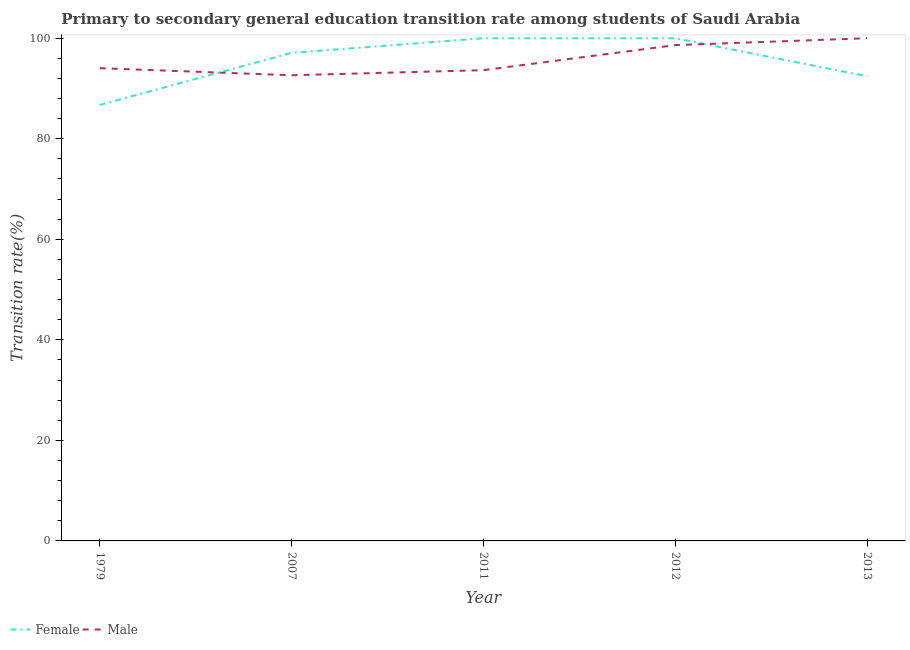How many different coloured lines are there?
Offer a very short reply. 2. Is the number of lines equal to the number of legend labels?
Your answer should be very brief. Yes. What is the transition rate among male students in 2013?
Make the answer very short. 100. Across all years, what is the minimum transition rate among male students?
Provide a short and direct response. 92.63. In which year was the transition rate among male students maximum?
Ensure brevity in your answer.  2013. In which year was the transition rate among female students minimum?
Ensure brevity in your answer.  1979. What is the total transition rate among female students in the graph?
Your response must be concise. 476.25. What is the difference between the transition rate among male students in 1979 and that in 2012?
Your answer should be very brief. -4.58. What is the difference between the transition rate among male students in 2013 and the transition rate among female students in 2007?
Make the answer very short. 2.91. What is the average transition rate among male students per year?
Your response must be concise. 95.79. In the year 2012, what is the difference between the transition rate among female students and transition rate among male students?
Your answer should be very brief. 1.37. In how many years, is the transition rate among male students greater than 40 %?
Keep it short and to the point. 5. What is the ratio of the transition rate among male students in 2011 to that in 2013?
Make the answer very short. 0.94. Is the transition rate among male students in 2007 less than that in 2013?
Your answer should be compact. Yes. Is the difference between the transition rate among male students in 2012 and 2013 greater than the difference between the transition rate among female students in 2012 and 2013?
Offer a terse response. No. What is the difference between the highest and the lowest transition rate among male students?
Your answer should be compact. 7.37. Is the transition rate among male students strictly greater than the transition rate among female students over the years?
Offer a very short reply. No. Is the transition rate among female students strictly less than the transition rate among male students over the years?
Provide a short and direct response. No. How many years are there in the graph?
Your answer should be very brief. 5. Does the graph contain any zero values?
Make the answer very short. No. Does the graph contain grids?
Your answer should be compact. No. Where does the legend appear in the graph?
Offer a terse response. Bottom left. How are the legend labels stacked?
Make the answer very short. Horizontal. What is the title of the graph?
Make the answer very short. Primary to secondary general education transition rate among students of Saudi Arabia. Does "Commercial service exports" appear as one of the legend labels in the graph?
Provide a short and direct response. No. What is the label or title of the Y-axis?
Offer a terse response. Transition rate(%). What is the Transition rate(%) of Female in 1979?
Offer a very short reply. 86.72. What is the Transition rate(%) of Male in 1979?
Provide a succinct answer. 94.04. What is the Transition rate(%) in Female in 2007?
Make the answer very short. 97.09. What is the Transition rate(%) of Male in 2007?
Provide a succinct answer. 92.63. What is the Transition rate(%) of Female in 2011?
Offer a terse response. 100. What is the Transition rate(%) in Male in 2011?
Offer a very short reply. 93.65. What is the Transition rate(%) in Female in 2012?
Make the answer very short. 100. What is the Transition rate(%) in Male in 2012?
Your response must be concise. 98.63. What is the Transition rate(%) in Female in 2013?
Provide a succinct answer. 92.43. Across all years, what is the maximum Transition rate(%) in Female?
Your answer should be compact. 100. Across all years, what is the maximum Transition rate(%) in Male?
Offer a terse response. 100. Across all years, what is the minimum Transition rate(%) of Female?
Your answer should be compact. 86.72. Across all years, what is the minimum Transition rate(%) of Male?
Offer a very short reply. 92.63. What is the total Transition rate(%) in Female in the graph?
Make the answer very short. 476.25. What is the total Transition rate(%) of Male in the graph?
Your response must be concise. 478.95. What is the difference between the Transition rate(%) of Female in 1979 and that in 2007?
Provide a short and direct response. -10.36. What is the difference between the Transition rate(%) of Male in 1979 and that in 2007?
Ensure brevity in your answer.  1.41. What is the difference between the Transition rate(%) of Female in 1979 and that in 2011?
Your response must be concise. -13.28. What is the difference between the Transition rate(%) in Male in 1979 and that in 2011?
Ensure brevity in your answer.  0.4. What is the difference between the Transition rate(%) of Female in 1979 and that in 2012?
Your answer should be very brief. -13.28. What is the difference between the Transition rate(%) of Male in 1979 and that in 2012?
Your answer should be compact. -4.58. What is the difference between the Transition rate(%) of Female in 1979 and that in 2013?
Your answer should be compact. -5.71. What is the difference between the Transition rate(%) in Male in 1979 and that in 2013?
Offer a very short reply. -5.96. What is the difference between the Transition rate(%) in Female in 2007 and that in 2011?
Your answer should be very brief. -2.91. What is the difference between the Transition rate(%) of Male in 2007 and that in 2011?
Give a very brief answer. -1.01. What is the difference between the Transition rate(%) of Female in 2007 and that in 2012?
Ensure brevity in your answer.  -2.91. What is the difference between the Transition rate(%) in Male in 2007 and that in 2012?
Keep it short and to the point. -5.99. What is the difference between the Transition rate(%) of Female in 2007 and that in 2013?
Keep it short and to the point. 4.65. What is the difference between the Transition rate(%) in Male in 2007 and that in 2013?
Offer a terse response. -7.37. What is the difference between the Transition rate(%) of Female in 2011 and that in 2012?
Offer a very short reply. 0. What is the difference between the Transition rate(%) of Male in 2011 and that in 2012?
Ensure brevity in your answer.  -4.98. What is the difference between the Transition rate(%) of Female in 2011 and that in 2013?
Provide a succinct answer. 7.57. What is the difference between the Transition rate(%) of Male in 2011 and that in 2013?
Provide a succinct answer. -6.35. What is the difference between the Transition rate(%) in Female in 2012 and that in 2013?
Make the answer very short. 7.57. What is the difference between the Transition rate(%) in Male in 2012 and that in 2013?
Keep it short and to the point. -1.37. What is the difference between the Transition rate(%) in Female in 1979 and the Transition rate(%) in Male in 2007?
Ensure brevity in your answer.  -5.91. What is the difference between the Transition rate(%) in Female in 1979 and the Transition rate(%) in Male in 2011?
Offer a very short reply. -6.92. What is the difference between the Transition rate(%) in Female in 1979 and the Transition rate(%) in Male in 2012?
Provide a succinct answer. -11.9. What is the difference between the Transition rate(%) in Female in 1979 and the Transition rate(%) in Male in 2013?
Your answer should be very brief. -13.28. What is the difference between the Transition rate(%) of Female in 2007 and the Transition rate(%) of Male in 2011?
Your answer should be very brief. 3.44. What is the difference between the Transition rate(%) of Female in 2007 and the Transition rate(%) of Male in 2012?
Offer a terse response. -1.54. What is the difference between the Transition rate(%) in Female in 2007 and the Transition rate(%) in Male in 2013?
Provide a succinct answer. -2.91. What is the difference between the Transition rate(%) of Female in 2011 and the Transition rate(%) of Male in 2012?
Offer a very short reply. 1.37. What is the difference between the Transition rate(%) of Female in 2011 and the Transition rate(%) of Male in 2013?
Your answer should be compact. 0. What is the average Transition rate(%) in Female per year?
Your response must be concise. 95.25. What is the average Transition rate(%) of Male per year?
Your response must be concise. 95.79. In the year 1979, what is the difference between the Transition rate(%) in Female and Transition rate(%) in Male?
Ensure brevity in your answer.  -7.32. In the year 2007, what is the difference between the Transition rate(%) in Female and Transition rate(%) in Male?
Ensure brevity in your answer.  4.46. In the year 2011, what is the difference between the Transition rate(%) in Female and Transition rate(%) in Male?
Offer a terse response. 6.35. In the year 2012, what is the difference between the Transition rate(%) in Female and Transition rate(%) in Male?
Give a very brief answer. 1.37. In the year 2013, what is the difference between the Transition rate(%) of Female and Transition rate(%) of Male?
Ensure brevity in your answer.  -7.57. What is the ratio of the Transition rate(%) in Female in 1979 to that in 2007?
Provide a short and direct response. 0.89. What is the ratio of the Transition rate(%) of Male in 1979 to that in 2007?
Your answer should be very brief. 1.02. What is the ratio of the Transition rate(%) in Female in 1979 to that in 2011?
Offer a terse response. 0.87. What is the ratio of the Transition rate(%) in Female in 1979 to that in 2012?
Offer a very short reply. 0.87. What is the ratio of the Transition rate(%) in Male in 1979 to that in 2012?
Make the answer very short. 0.95. What is the ratio of the Transition rate(%) in Female in 1979 to that in 2013?
Provide a succinct answer. 0.94. What is the ratio of the Transition rate(%) of Male in 1979 to that in 2013?
Offer a very short reply. 0.94. What is the ratio of the Transition rate(%) in Female in 2007 to that in 2011?
Offer a very short reply. 0.97. What is the ratio of the Transition rate(%) in Female in 2007 to that in 2012?
Ensure brevity in your answer.  0.97. What is the ratio of the Transition rate(%) in Male in 2007 to that in 2012?
Ensure brevity in your answer.  0.94. What is the ratio of the Transition rate(%) in Female in 2007 to that in 2013?
Your answer should be very brief. 1.05. What is the ratio of the Transition rate(%) of Male in 2007 to that in 2013?
Give a very brief answer. 0.93. What is the ratio of the Transition rate(%) of Female in 2011 to that in 2012?
Make the answer very short. 1. What is the ratio of the Transition rate(%) in Male in 2011 to that in 2012?
Offer a terse response. 0.95. What is the ratio of the Transition rate(%) of Female in 2011 to that in 2013?
Make the answer very short. 1.08. What is the ratio of the Transition rate(%) of Male in 2011 to that in 2013?
Ensure brevity in your answer.  0.94. What is the ratio of the Transition rate(%) in Female in 2012 to that in 2013?
Keep it short and to the point. 1.08. What is the ratio of the Transition rate(%) in Male in 2012 to that in 2013?
Give a very brief answer. 0.99. What is the difference between the highest and the second highest Transition rate(%) of Female?
Provide a succinct answer. 0. What is the difference between the highest and the second highest Transition rate(%) in Male?
Provide a succinct answer. 1.37. What is the difference between the highest and the lowest Transition rate(%) of Female?
Ensure brevity in your answer.  13.28. What is the difference between the highest and the lowest Transition rate(%) of Male?
Your response must be concise. 7.37. 